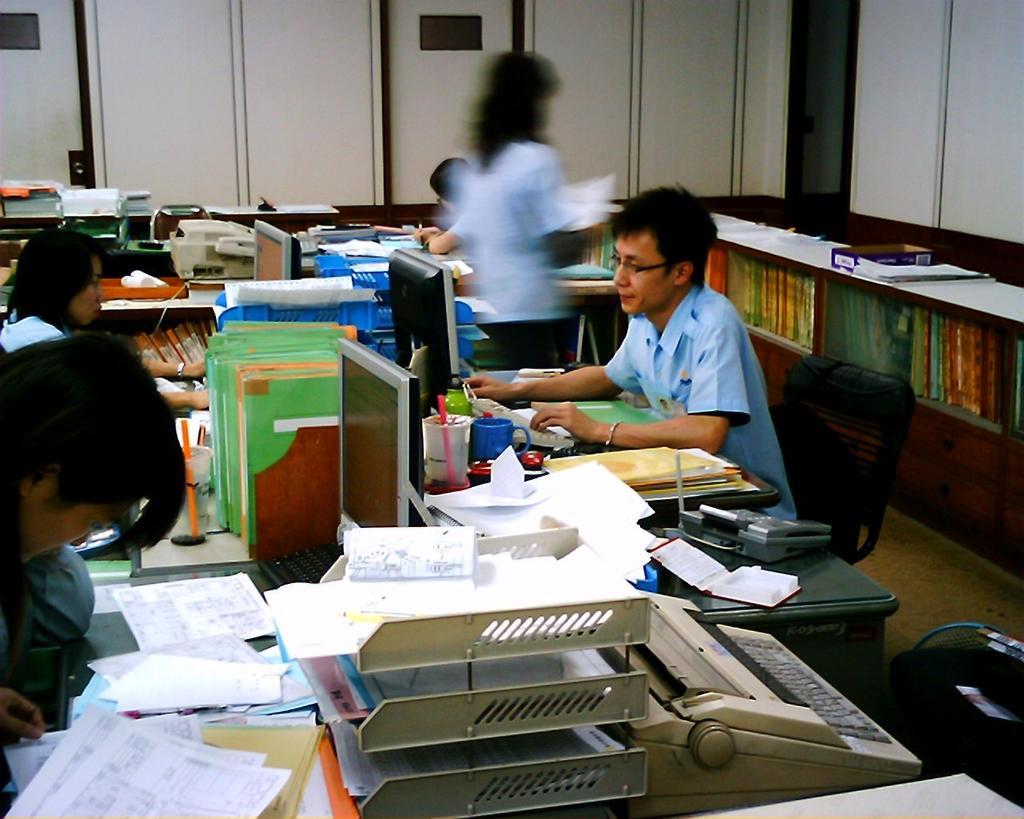Please provide a concise description of this image. In this image I can see few people are sitting on chairs. I can also see number of files, papers on these tables. I can also see few monitors. I can see most of them are wearing same dresses. 